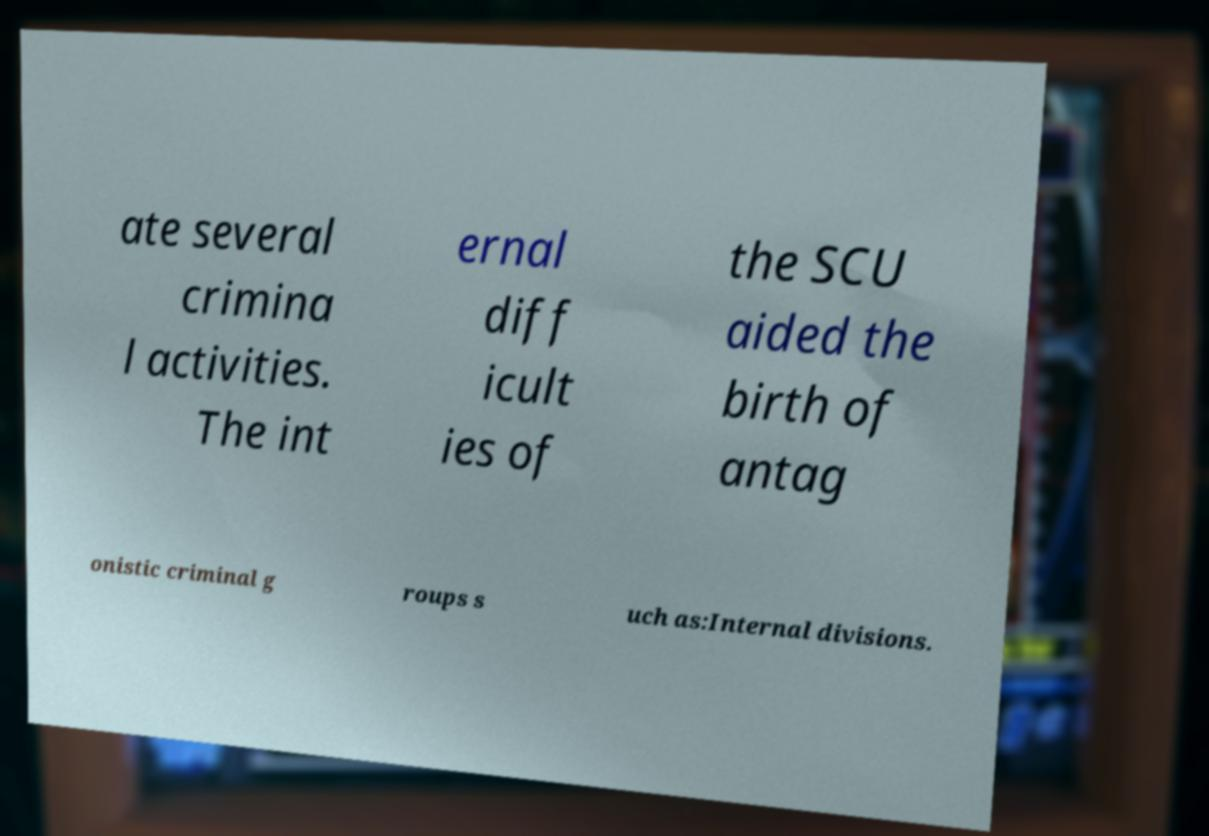Please read and relay the text visible in this image. What does it say? ate several crimina l activities. The int ernal diff icult ies of the SCU aided the birth of antag onistic criminal g roups s uch as:Internal divisions. 